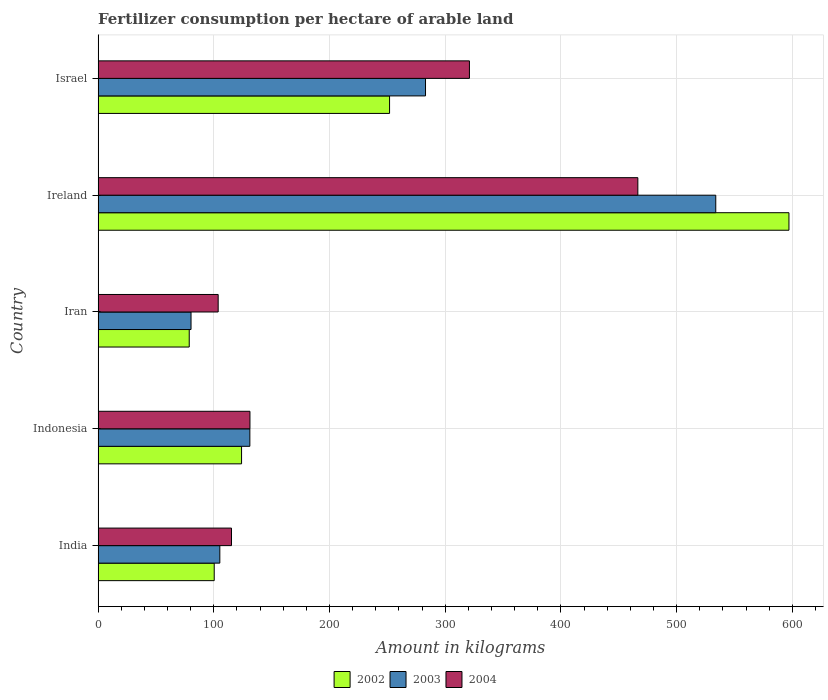How many different coloured bars are there?
Your answer should be very brief. 3. How many bars are there on the 1st tick from the top?
Your answer should be compact. 3. In how many cases, is the number of bars for a given country not equal to the number of legend labels?
Ensure brevity in your answer.  0. What is the amount of fertilizer consumption in 2003 in Israel?
Provide a succinct answer. 282.93. Across all countries, what is the maximum amount of fertilizer consumption in 2002?
Offer a very short reply. 597.02. Across all countries, what is the minimum amount of fertilizer consumption in 2002?
Ensure brevity in your answer.  78.74. In which country was the amount of fertilizer consumption in 2002 maximum?
Your response must be concise. Ireland. In which country was the amount of fertilizer consumption in 2002 minimum?
Make the answer very short. Iran. What is the total amount of fertilizer consumption in 2002 in the graph?
Offer a very short reply. 1151.91. What is the difference between the amount of fertilizer consumption in 2002 in Iran and that in Israel?
Keep it short and to the point. -173.12. What is the difference between the amount of fertilizer consumption in 2002 in India and the amount of fertilizer consumption in 2003 in Ireland?
Your response must be concise. -433.44. What is the average amount of fertilizer consumption in 2004 per country?
Offer a terse response. 227.51. What is the difference between the amount of fertilizer consumption in 2004 and amount of fertilizer consumption in 2003 in Iran?
Provide a succinct answer. 23.46. What is the ratio of the amount of fertilizer consumption in 2003 in Ireland to that in Israel?
Keep it short and to the point. 1.89. Is the amount of fertilizer consumption in 2004 in India less than that in Indonesia?
Keep it short and to the point. Yes. What is the difference between the highest and the second highest amount of fertilizer consumption in 2003?
Your answer should be very brief. 250.84. What is the difference between the highest and the lowest amount of fertilizer consumption in 2003?
Your response must be concise. 453.48. Is the sum of the amount of fertilizer consumption in 2002 in India and Iran greater than the maximum amount of fertilizer consumption in 2004 across all countries?
Your answer should be very brief. No. Is it the case that in every country, the sum of the amount of fertilizer consumption in 2003 and amount of fertilizer consumption in 2004 is greater than the amount of fertilizer consumption in 2002?
Make the answer very short. Yes. How many bars are there?
Offer a very short reply. 15. How many countries are there in the graph?
Ensure brevity in your answer.  5. Does the graph contain any zero values?
Offer a very short reply. No. Does the graph contain grids?
Provide a succinct answer. Yes. Where does the legend appear in the graph?
Ensure brevity in your answer.  Bottom center. How many legend labels are there?
Provide a succinct answer. 3. How are the legend labels stacked?
Your answer should be very brief. Horizontal. What is the title of the graph?
Offer a very short reply. Fertilizer consumption per hectare of arable land. What is the label or title of the X-axis?
Keep it short and to the point. Amount in kilograms. What is the label or title of the Y-axis?
Your response must be concise. Country. What is the Amount in kilograms in 2002 in India?
Your answer should be very brief. 100.33. What is the Amount in kilograms in 2003 in India?
Ensure brevity in your answer.  105.18. What is the Amount in kilograms of 2004 in India?
Your answer should be compact. 115.27. What is the Amount in kilograms in 2002 in Indonesia?
Keep it short and to the point. 123.96. What is the Amount in kilograms in 2003 in Indonesia?
Your answer should be compact. 131.13. What is the Amount in kilograms of 2004 in Indonesia?
Provide a short and direct response. 131.21. What is the Amount in kilograms in 2002 in Iran?
Your response must be concise. 78.74. What is the Amount in kilograms of 2003 in Iran?
Your response must be concise. 80.29. What is the Amount in kilograms in 2004 in Iran?
Make the answer very short. 103.75. What is the Amount in kilograms of 2002 in Ireland?
Offer a very short reply. 597.02. What is the Amount in kilograms of 2003 in Ireland?
Keep it short and to the point. 533.77. What is the Amount in kilograms in 2004 in Ireland?
Provide a short and direct response. 466.43. What is the Amount in kilograms of 2002 in Israel?
Your response must be concise. 251.86. What is the Amount in kilograms of 2003 in Israel?
Ensure brevity in your answer.  282.93. What is the Amount in kilograms of 2004 in Israel?
Keep it short and to the point. 320.9. Across all countries, what is the maximum Amount in kilograms in 2002?
Provide a succinct answer. 597.02. Across all countries, what is the maximum Amount in kilograms of 2003?
Ensure brevity in your answer.  533.77. Across all countries, what is the maximum Amount in kilograms of 2004?
Your answer should be compact. 466.43. Across all countries, what is the minimum Amount in kilograms of 2002?
Provide a short and direct response. 78.74. Across all countries, what is the minimum Amount in kilograms of 2003?
Keep it short and to the point. 80.29. Across all countries, what is the minimum Amount in kilograms in 2004?
Make the answer very short. 103.75. What is the total Amount in kilograms of 2002 in the graph?
Offer a very short reply. 1151.91. What is the total Amount in kilograms in 2003 in the graph?
Offer a terse response. 1133.31. What is the total Amount in kilograms in 2004 in the graph?
Your answer should be compact. 1137.56. What is the difference between the Amount in kilograms in 2002 in India and that in Indonesia?
Offer a very short reply. -23.63. What is the difference between the Amount in kilograms of 2003 in India and that in Indonesia?
Your response must be concise. -25.95. What is the difference between the Amount in kilograms in 2004 in India and that in Indonesia?
Offer a very short reply. -15.94. What is the difference between the Amount in kilograms of 2002 in India and that in Iran?
Your answer should be compact. 21.59. What is the difference between the Amount in kilograms of 2003 in India and that in Iran?
Give a very brief answer. 24.89. What is the difference between the Amount in kilograms in 2004 in India and that in Iran?
Offer a very short reply. 11.52. What is the difference between the Amount in kilograms in 2002 in India and that in Ireland?
Give a very brief answer. -496.69. What is the difference between the Amount in kilograms of 2003 in India and that in Ireland?
Offer a terse response. -428.6. What is the difference between the Amount in kilograms of 2004 in India and that in Ireland?
Your response must be concise. -351.16. What is the difference between the Amount in kilograms of 2002 in India and that in Israel?
Your answer should be compact. -151.53. What is the difference between the Amount in kilograms of 2003 in India and that in Israel?
Offer a terse response. -177.76. What is the difference between the Amount in kilograms of 2004 in India and that in Israel?
Your answer should be very brief. -205.63. What is the difference between the Amount in kilograms in 2002 in Indonesia and that in Iran?
Your response must be concise. 45.22. What is the difference between the Amount in kilograms of 2003 in Indonesia and that in Iran?
Make the answer very short. 50.84. What is the difference between the Amount in kilograms of 2004 in Indonesia and that in Iran?
Your response must be concise. 27.46. What is the difference between the Amount in kilograms of 2002 in Indonesia and that in Ireland?
Keep it short and to the point. -473.06. What is the difference between the Amount in kilograms of 2003 in Indonesia and that in Ireland?
Give a very brief answer. -402.64. What is the difference between the Amount in kilograms of 2004 in Indonesia and that in Ireland?
Your answer should be compact. -335.22. What is the difference between the Amount in kilograms of 2002 in Indonesia and that in Israel?
Make the answer very short. -127.9. What is the difference between the Amount in kilograms in 2003 in Indonesia and that in Israel?
Make the answer very short. -151.8. What is the difference between the Amount in kilograms of 2004 in Indonesia and that in Israel?
Your response must be concise. -189.69. What is the difference between the Amount in kilograms in 2002 in Iran and that in Ireland?
Your answer should be very brief. -518.28. What is the difference between the Amount in kilograms of 2003 in Iran and that in Ireland?
Keep it short and to the point. -453.48. What is the difference between the Amount in kilograms in 2004 in Iran and that in Ireland?
Offer a very short reply. -362.68. What is the difference between the Amount in kilograms of 2002 in Iran and that in Israel?
Your response must be concise. -173.12. What is the difference between the Amount in kilograms in 2003 in Iran and that in Israel?
Your answer should be very brief. -202.64. What is the difference between the Amount in kilograms in 2004 in Iran and that in Israel?
Your answer should be compact. -217.15. What is the difference between the Amount in kilograms in 2002 in Ireland and that in Israel?
Provide a short and direct response. 345.16. What is the difference between the Amount in kilograms in 2003 in Ireland and that in Israel?
Provide a short and direct response. 250.84. What is the difference between the Amount in kilograms of 2004 in Ireland and that in Israel?
Keep it short and to the point. 145.53. What is the difference between the Amount in kilograms of 2002 in India and the Amount in kilograms of 2003 in Indonesia?
Make the answer very short. -30.8. What is the difference between the Amount in kilograms of 2002 in India and the Amount in kilograms of 2004 in Indonesia?
Ensure brevity in your answer.  -30.88. What is the difference between the Amount in kilograms in 2003 in India and the Amount in kilograms in 2004 in Indonesia?
Keep it short and to the point. -26.03. What is the difference between the Amount in kilograms of 2002 in India and the Amount in kilograms of 2003 in Iran?
Ensure brevity in your answer.  20.04. What is the difference between the Amount in kilograms in 2002 in India and the Amount in kilograms in 2004 in Iran?
Provide a short and direct response. -3.42. What is the difference between the Amount in kilograms of 2003 in India and the Amount in kilograms of 2004 in Iran?
Offer a very short reply. 1.43. What is the difference between the Amount in kilograms of 2002 in India and the Amount in kilograms of 2003 in Ireland?
Keep it short and to the point. -433.44. What is the difference between the Amount in kilograms of 2002 in India and the Amount in kilograms of 2004 in Ireland?
Your answer should be very brief. -366.1. What is the difference between the Amount in kilograms of 2003 in India and the Amount in kilograms of 2004 in Ireland?
Keep it short and to the point. -361.25. What is the difference between the Amount in kilograms in 2002 in India and the Amount in kilograms in 2003 in Israel?
Make the answer very short. -182.61. What is the difference between the Amount in kilograms in 2002 in India and the Amount in kilograms in 2004 in Israel?
Your response must be concise. -220.57. What is the difference between the Amount in kilograms in 2003 in India and the Amount in kilograms in 2004 in Israel?
Offer a terse response. -215.72. What is the difference between the Amount in kilograms of 2002 in Indonesia and the Amount in kilograms of 2003 in Iran?
Your answer should be compact. 43.67. What is the difference between the Amount in kilograms of 2002 in Indonesia and the Amount in kilograms of 2004 in Iran?
Keep it short and to the point. 20.21. What is the difference between the Amount in kilograms of 2003 in Indonesia and the Amount in kilograms of 2004 in Iran?
Give a very brief answer. 27.38. What is the difference between the Amount in kilograms in 2002 in Indonesia and the Amount in kilograms in 2003 in Ireland?
Give a very brief answer. -409.81. What is the difference between the Amount in kilograms in 2002 in Indonesia and the Amount in kilograms in 2004 in Ireland?
Ensure brevity in your answer.  -342.47. What is the difference between the Amount in kilograms of 2003 in Indonesia and the Amount in kilograms of 2004 in Ireland?
Ensure brevity in your answer.  -335.3. What is the difference between the Amount in kilograms of 2002 in Indonesia and the Amount in kilograms of 2003 in Israel?
Make the answer very short. -158.98. What is the difference between the Amount in kilograms of 2002 in Indonesia and the Amount in kilograms of 2004 in Israel?
Make the answer very short. -196.94. What is the difference between the Amount in kilograms in 2003 in Indonesia and the Amount in kilograms in 2004 in Israel?
Keep it short and to the point. -189.77. What is the difference between the Amount in kilograms in 2002 in Iran and the Amount in kilograms in 2003 in Ireland?
Provide a short and direct response. -455.03. What is the difference between the Amount in kilograms of 2002 in Iran and the Amount in kilograms of 2004 in Ireland?
Offer a terse response. -387.69. What is the difference between the Amount in kilograms in 2003 in Iran and the Amount in kilograms in 2004 in Ireland?
Provide a succinct answer. -386.14. What is the difference between the Amount in kilograms of 2002 in Iran and the Amount in kilograms of 2003 in Israel?
Offer a very short reply. -204.19. What is the difference between the Amount in kilograms in 2002 in Iran and the Amount in kilograms in 2004 in Israel?
Your answer should be very brief. -242.16. What is the difference between the Amount in kilograms in 2003 in Iran and the Amount in kilograms in 2004 in Israel?
Provide a short and direct response. -240.61. What is the difference between the Amount in kilograms in 2002 in Ireland and the Amount in kilograms in 2003 in Israel?
Provide a succinct answer. 314.08. What is the difference between the Amount in kilograms of 2002 in Ireland and the Amount in kilograms of 2004 in Israel?
Provide a short and direct response. 276.12. What is the difference between the Amount in kilograms of 2003 in Ireland and the Amount in kilograms of 2004 in Israel?
Ensure brevity in your answer.  212.87. What is the average Amount in kilograms of 2002 per country?
Offer a very short reply. 230.38. What is the average Amount in kilograms in 2003 per country?
Make the answer very short. 226.66. What is the average Amount in kilograms in 2004 per country?
Provide a succinct answer. 227.51. What is the difference between the Amount in kilograms in 2002 and Amount in kilograms in 2003 in India?
Your answer should be very brief. -4.85. What is the difference between the Amount in kilograms of 2002 and Amount in kilograms of 2004 in India?
Ensure brevity in your answer.  -14.94. What is the difference between the Amount in kilograms in 2003 and Amount in kilograms in 2004 in India?
Make the answer very short. -10.09. What is the difference between the Amount in kilograms of 2002 and Amount in kilograms of 2003 in Indonesia?
Your answer should be compact. -7.17. What is the difference between the Amount in kilograms in 2002 and Amount in kilograms in 2004 in Indonesia?
Offer a very short reply. -7.25. What is the difference between the Amount in kilograms in 2003 and Amount in kilograms in 2004 in Indonesia?
Give a very brief answer. -0.08. What is the difference between the Amount in kilograms of 2002 and Amount in kilograms of 2003 in Iran?
Keep it short and to the point. -1.55. What is the difference between the Amount in kilograms of 2002 and Amount in kilograms of 2004 in Iran?
Ensure brevity in your answer.  -25.01. What is the difference between the Amount in kilograms in 2003 and Amount in kilograms in 2004 in Iran?
Provide a succinct answer. -23.46. What is the difference between the Amount in kilograms of 2002 and Amount in kilograms of 2003 in Ireland?
Your response must be concise. 63.24. What is the difference between the Amount in kilograms in 2002 and Amount in kilograms in 2004 in Ireland?
Give a very brief answer. 130.59. What is the difference between the Amount in kilograms in 2003 and Amount in kilograms in 2004 in Ireland?
Offer a very short reply. 67.34. What is the difference between the Amount in kilograms of 2002 and Amount in kilograms of 2003 in Israel?
Provide a short and direct response. -31.07. What is the difference between the Amount in kilograms in 2002 and Amount in kilograms in 2004 in Israel?
Your answer should be compact. -69.04. What is the difference between the Amount in kilograms in 2003 and Amount in kilograms in 2004 in Israel?
Your response must be concise. -37.97. What is the ratio of the Amount in kilograms in 2002 in India to that in Indonesia?
Give a very brief answer. 0.81. What is the ratio of the Amount in kilograms of 2003 in India to that in Indonesia?
Keep it short and to the point. 0.8. What is the ratio of the Amount in kilograms in 2004 in India to that in Indonesia?
Give a very brief answer. 0.88. What is the ratio of the Amount in kilograms of 2002 in India to that in Iran?
Your answer should be very brief. 1.27. What is the ratio of the Amount in kilograms of 2003 in India to that in Iran?
Offer a terse response. 1.31. What is the ratio of the Amount in kilograms in 2004 in India to that in Iran?
Provide a short and direct response. 1.11. What is the ratio of the Amount in kilograms in 2002 in India to that in Ireland?
Provide a succinct answer. 0.17. What is the ratio of the Amount in kilograms of 2003 in India to that in Ireland?
Your answer should be compact. 0.2. What is the ratio of the Amount in kilograms in 2004 in India to that in Ireland?
Give a very brief answer. 0.25. What is the ratio of the Amount in kilograms in 2002 in India to that in Israel?
Your answer should be compact. 0.4. What is the ratio of the Amount in kilograms in 2003 in India to that in Israel?
Keep it short and to the point. 0.37. What is the ratio of the Amount in kilograms of 2004 in India to that in Israel?
Give a very brief answer. 0.36. What is the ratio of the Amount in kilograms in 2002 in Indonesia to that in Iran?
Provide a succinct answer. 1.57. What is the ratio of the Amount in kilograms in 2003 in Indonesia to that in Iran?
Keep it short and to the point. 1.63. What is the ratio of the Amount in kilograms of 2004 in Indonesia to that in Iran?
Provide a short and direct response. 1.26. What is the ratio of the Amount in kilograms of 2002 in Indonesia to that in Ireland?
Offer a very short reply. 0.21. What is the ratio of the Amount in kilograms in 2003 in Indonesia to that in Ireland?
Ensure brevity in your answer.  0.25. What is the ratio of the Amount in kilograms in 2004 in Indonesia to that in Ireland?
Keep it short and to the point. 0.28. What is the ratio of the Amount in kilograms of 2002 in Indonesia to that in Israel?
Make the answer very short. 0.49. What is the ratio of the Amount in kilograms in 2003 in Indonesia to that in Israel?
Keep it short and to the point. 0.46. What is the ratio of the Amount in kilograms in 2004 in Indonesia to that in Israel?
Provide a succinct answer. 0.41. What is the ratio of the Amount in kilograms of 2002 in Iran to that in Ireland?
Offer a very short reply. 0.13. What is the ratio of the Amount in kilograms in 2003 in Iran to that in Ireland?
Provide a short and direct response. 0.15. What is the ratio of the Amount in kilograms in 2004 in Iran to that in Ireland?
Your response must be concise. 0.22. What is the ratio of the Amount in kilograms of 2002 in Iran to that in Israel?
Provide a succinct answer. 0.31. What is the ratio of the Amount in kilograms of 2003 in Iran to that in Israel?
Your answer should be very brief. 0.28. What is the ratio of the Amount in kilograms of 2004 in Iran to that in Israel?
Provide a succinct answer. 0.32. What is the ratio of the Amount in kilograms of 2002 in Ireland to that in Israel?
Offer a terse response. 2.37. What is the ratio of the Amount in kilograms of 2003 in Ireland to that in Israel?
Make the answer very short. 1.89. What is the ratio of the Amount in kilograms of 2004 in Ireland to that in Israel?
Offer a terse response. 1.45. What is the difference between the highest and the second highest Amount in kilograms in 2002?
Keep it short and to the point. 345.16. What is the difference between the highest and the second highest Amount in kilograms of 2003?
Your answer should be compact. 250.84. What is the difference between the highest and the second highest Amount in kilograms in 2004?
Offer a terse response. 145.53. What is the difference between the highest and the lowest Amount in kilograms in 2002?
Keep it short and to the point. 518.28. What is the difference between the highest and the lowest Amount in kilograms in 2003?
Ensure brevity in your answer.  453.48. What is the difference between the highest and the lowest Amount in kilograms of 2004?
Make the answer very short. 362.68. 